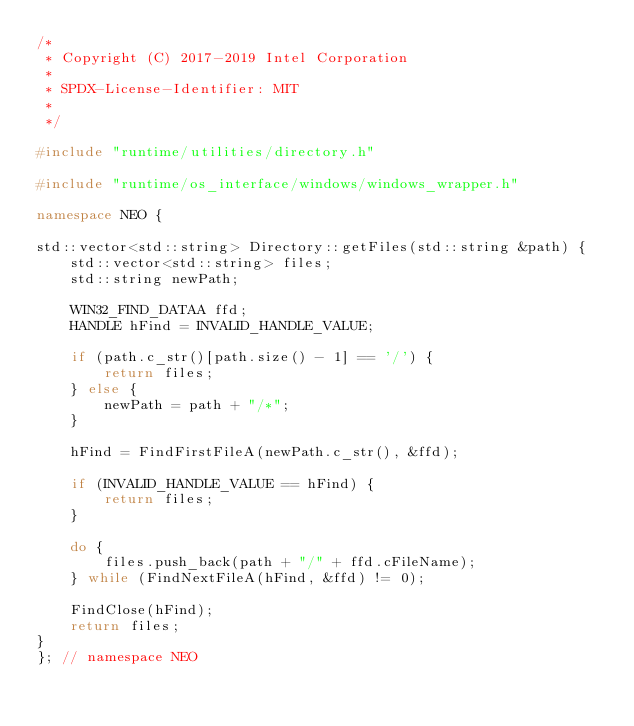<code> <loc_0><loc_0><loc_500><loc_500><_C++_>/*
 * Copyright (C) 2017-2019 Intel Corporation
 *
 * SPDX-License-Identifier: MIT
 *
 */

#include "runtime/utilities/directory.h"

#include "runtime/os_interface/windows/windows_wrapper.h"

namespace NEO {

std::vector<std::string> Directory::getFiles(std::string &path) {
    std::vector<std::string> files;
    std::string newPath;

    WIN32_FIND_DATAA ffd;
    HANDLE hFind = INVALID_HANDLE_VALUE;

    if (path.c_str()[path.size() - 1] == '/') {
        return files;
    } else {
        newPath = path + "/*";
    }

    hFind = FindFirstFileA(newPath.c_str(), &ffd);

    if (INVALID_HANDLE_VALUE == hFind) {
        return files;
    }

    do {
        files.push_back(path + "/" + ffd.cFileName);
    } while (FindNextFileA(hFind, &ffd) != 0);

    FindClose(hFind);
    return files;
}
}; // namespace NEO
</code> 